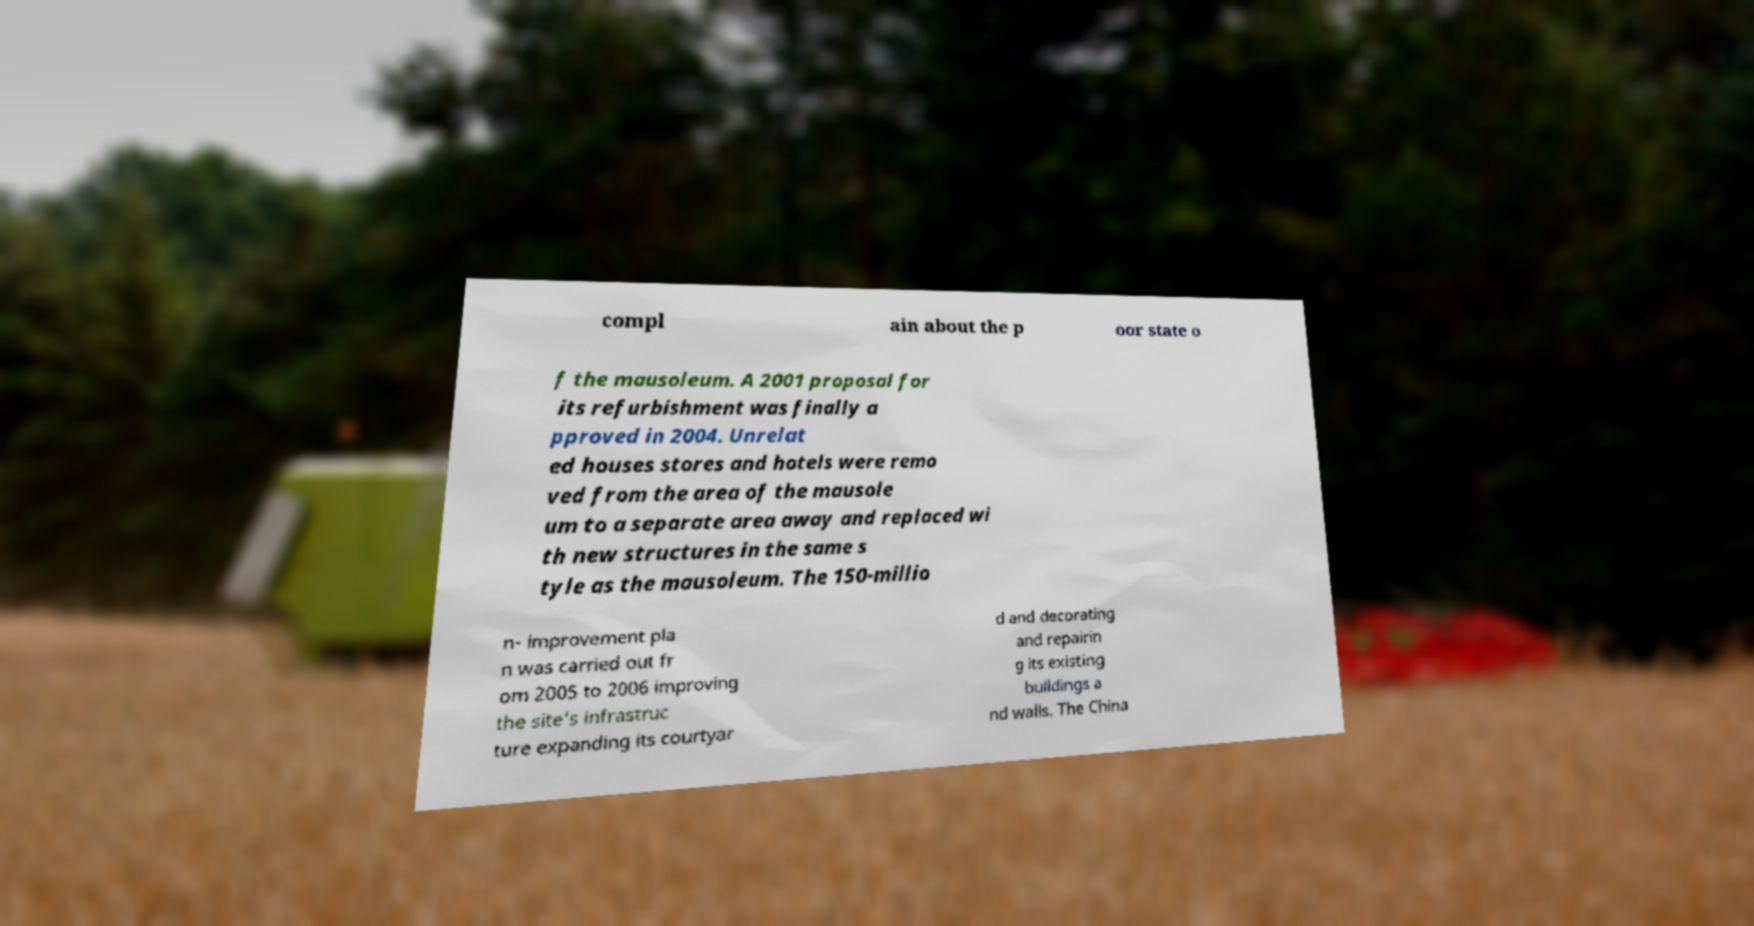Please read and relay the text visible in this image. What does it say? compl ain about the p oor state o f the mausoleum. A 2001 proposal for its refurbishment was finally a pproved in 2004. Unrelat ed houses stores and hotels were remo ved from the area of the mausole um to a separate area away and replaced wi th new structures in the same s tyle as the mausoleum. The 150-millio n- improvement pla n was carried out fr om 2005 to 2006 improving the site's infrastruc ture expanding its courtyar d and decorating and repairin g its existing buildings a nd walls. The China 